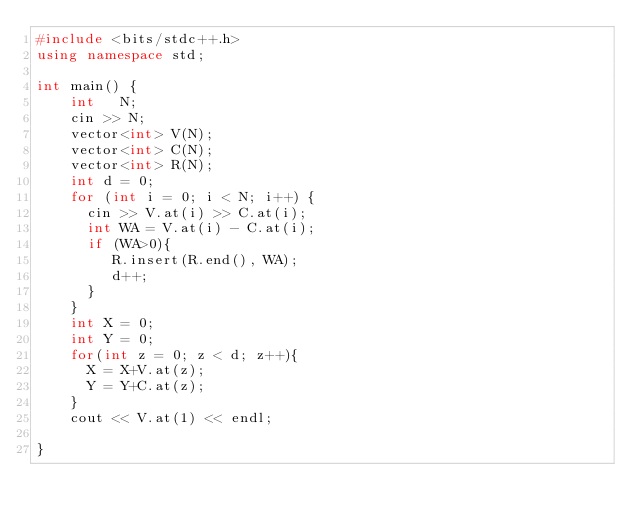<code> <loc_0><loc_0><loc_500><loc_500><_C++_>#include <bits/stdc++.h>
using namespace std;
     
int main() {
    int   N;
    cin >> N;
    vector<int> V(N);
    vector<int> C(N);
    vector<int> R(N);
    int d = 0;
    for (int i = 0; i < N; i++) {
      cin >> V.at(i) >> C.at(i);
      int WA = V.at(i) - C.at(i);
      if (WA>0){
         R.insert(R.end(), WA);
         d++;
      }
    }
    int X = 0;
    int Y = 0;
    for(int z = 0; z < d; z++){
      X = X+V.at(z);
      Y = Y+C.at(z);
    }
    cout << V.at(1) << endl;
        
}</code> 